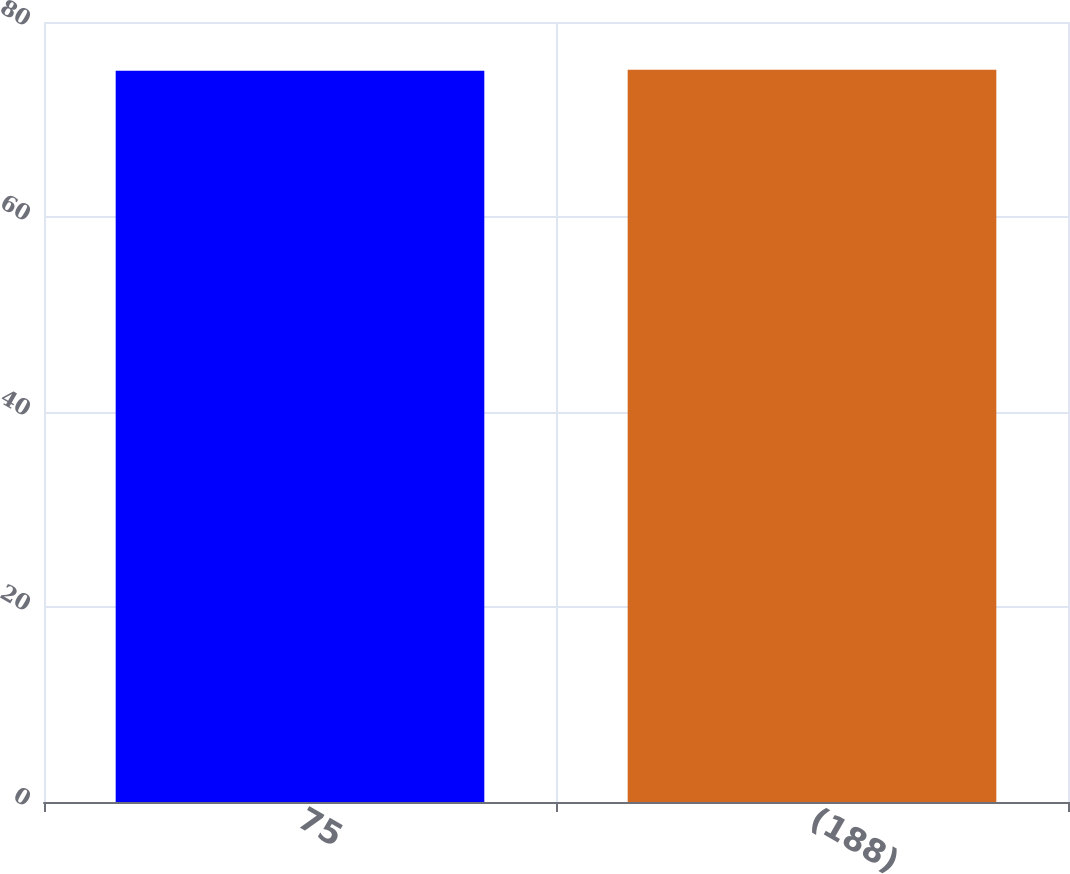<chart> <loc_0><loc_0><loc_500><loc_500><bar_chart><fcel>75<fcel>(188)<nl><fcel>75<fcel>75.1<nl></chart> 